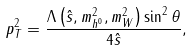<formula> <loc_0><loc_0><loc_500><loc_500>p _ { T } ^ { 2 } = \frac { \Lambda \left ( \hat { s } , m _ { h ^ { 0 } } ^ { 2 } , m _ { W } ^ { 2 } \right ) \sin ^ { 2 } \theta } { 4 \hat { s } } ,</formula> 